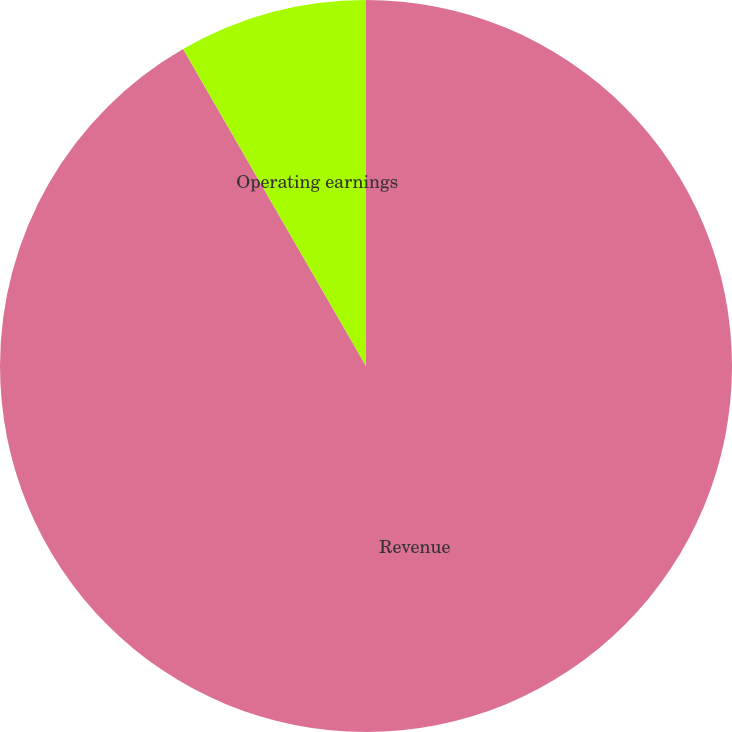<chart> <loc_0><loc_0><loc_500><loc_500><pie_chart><fcel>Revenue<fcel>Operating earnings<nl><fcel>91.67%<fcel>8.33%<nl></chart> 